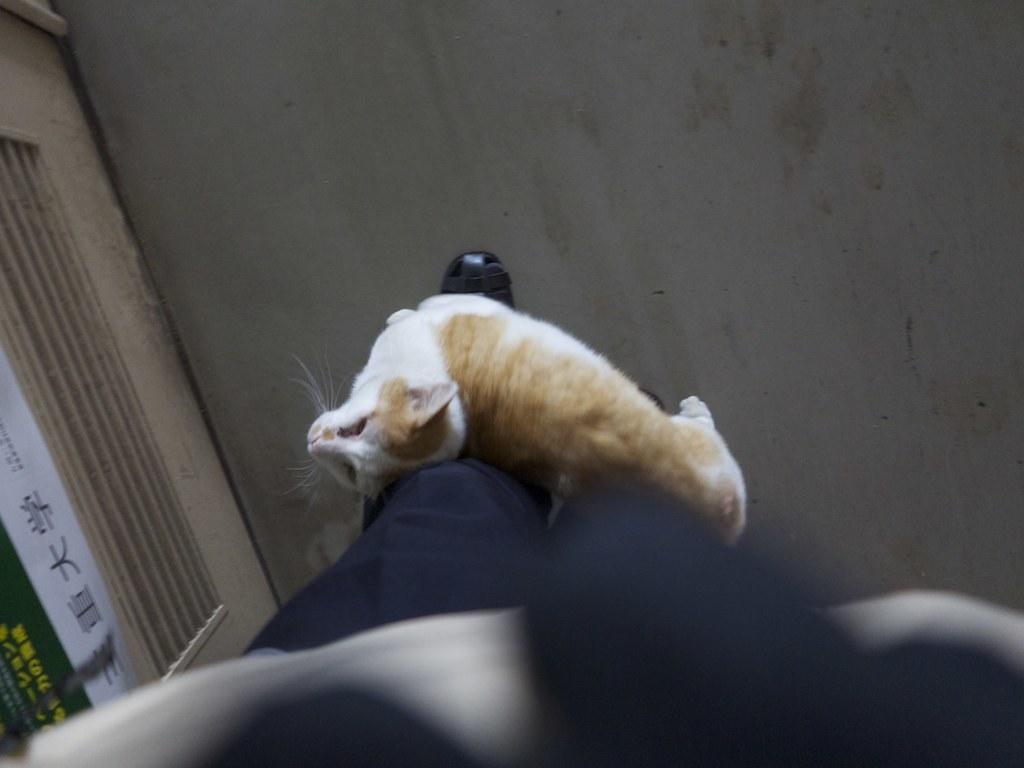Describe this image in one or two sentences. In this image I can see a person's legs and a cat on the floor. Here I can see something written on an object. 